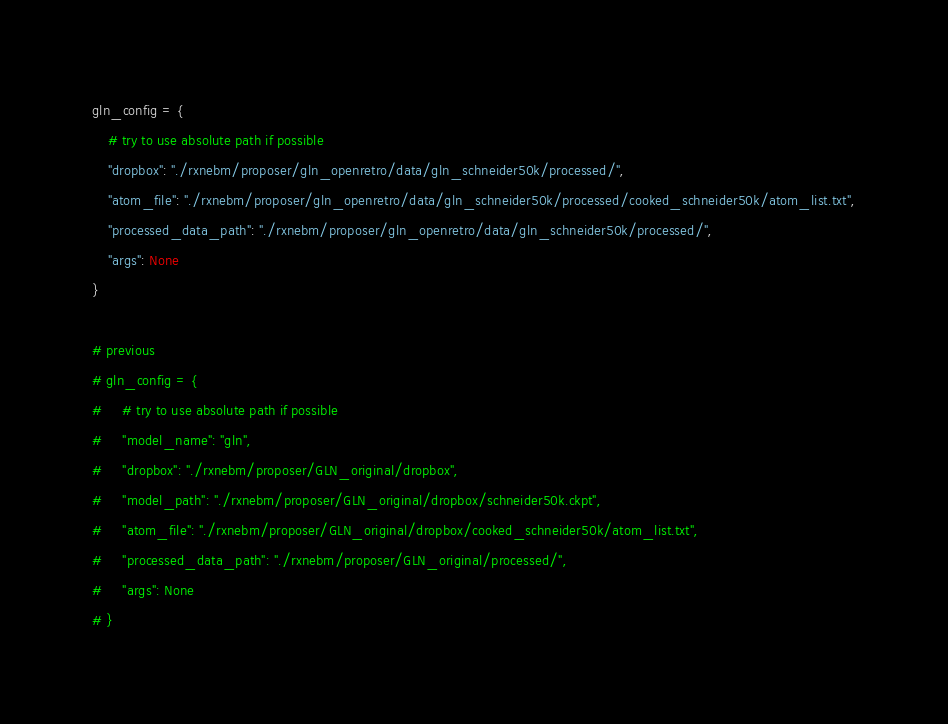Convert code to text. <code><loc_0><loc_0><loc_500><loc_500><_Python_>gln_config = {
    # try to use absolute path if possible
    "dropbox": "./rxnebm/proposer/gln_openretro/data/gln_schneider50k/processed/",
    "atom_file": "./rxnebm/proposer/gln_openretro/data/gln_schneider50k/processed/cooked_schneider50k/atom_list.txt",
    "processed_data_path": "./rxnebm/proposer/gln_openretro/data/gln_schneider50k/processed/",
    "args": None
}

# previous
# gln_config = {
#     # try to use absolute path if possible
#     "model_name": "gln",
#     "dropbox": "./rxnebm/proposer/GLN_original/dropbox",
#     "model_path": "./rxnebm/proposer/GLN_original/dropbox/schneider50k.ckpt",
#     "atom_file": "./rxnebm/proposer/GLN_original/dropbox/cooked_schneider50k/atom_list.txt",
#     "processed_data_path": "./rxnebm/proposer/GLN_original/processed/",
#     "args": None
# }
</code> 